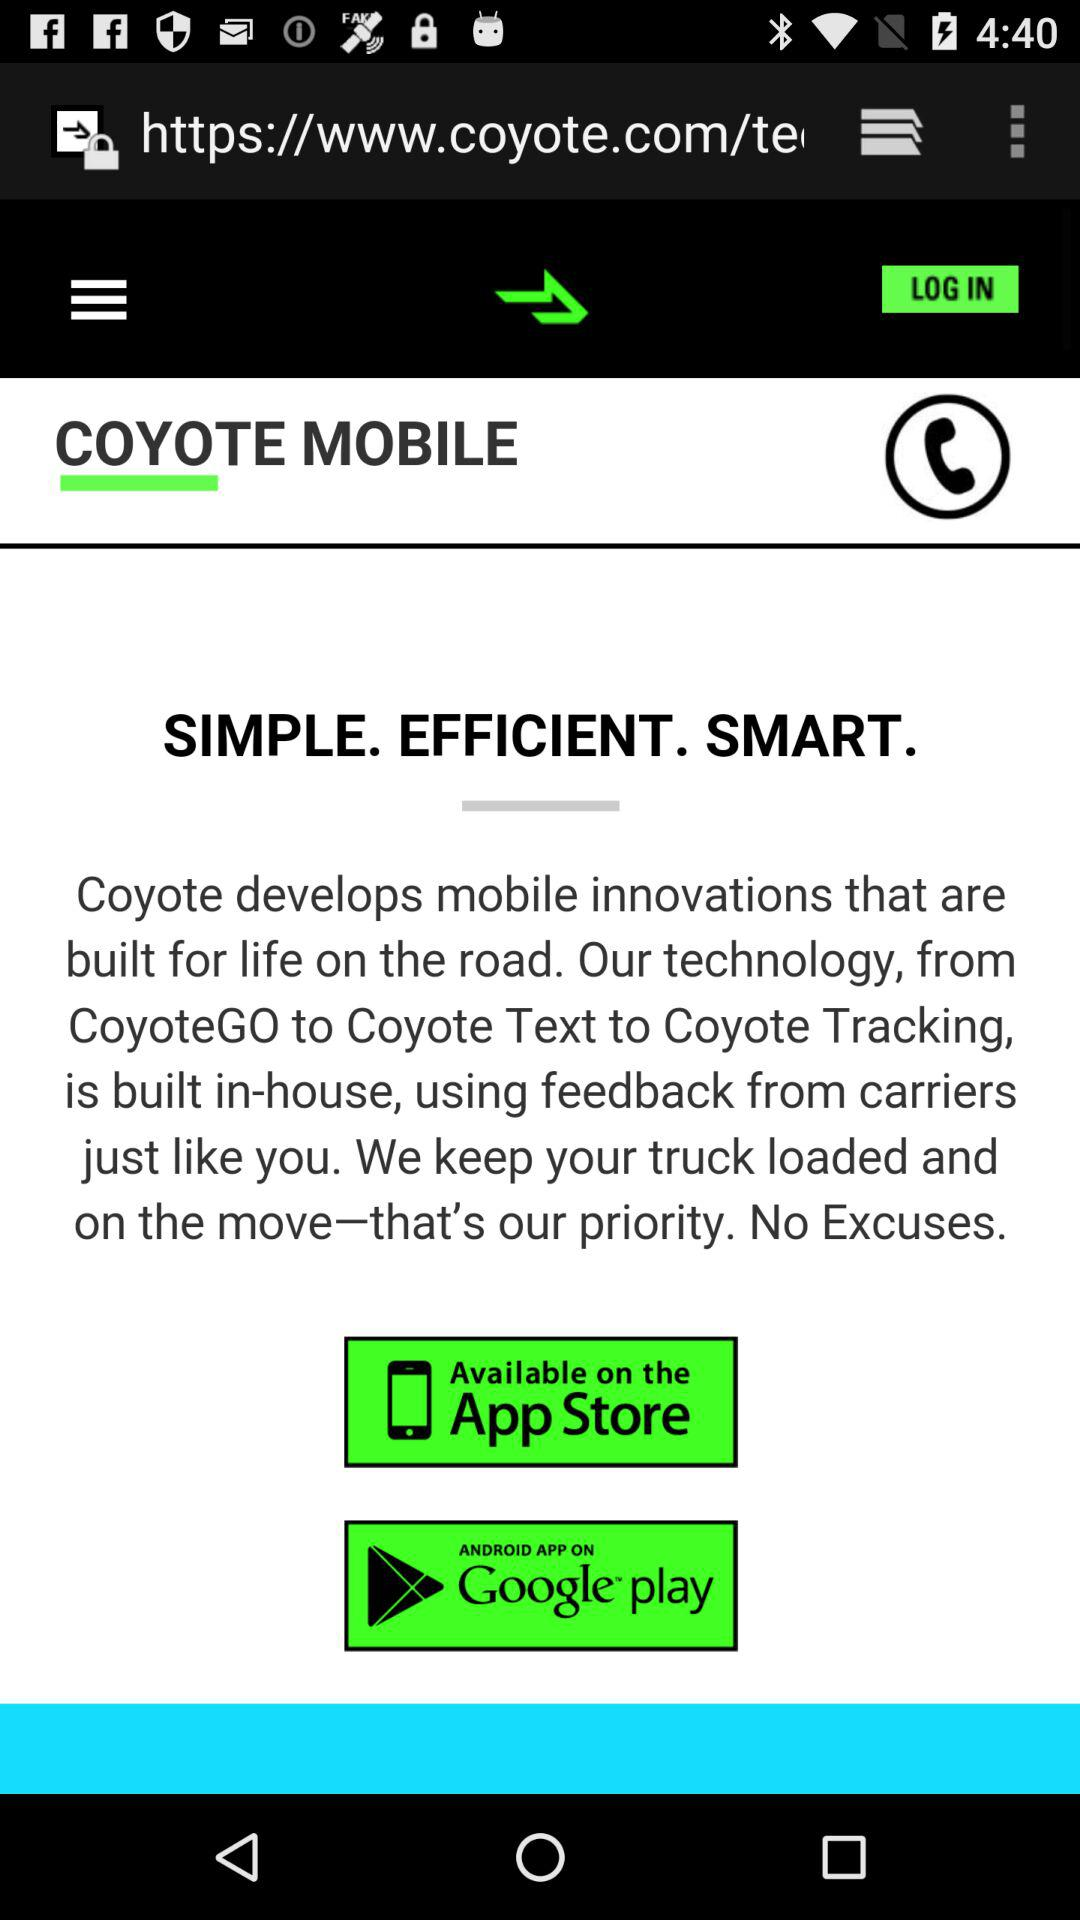What is Coyote Mobile?
When the provided information is insufficient, respond with <no answer>. <no answer> 